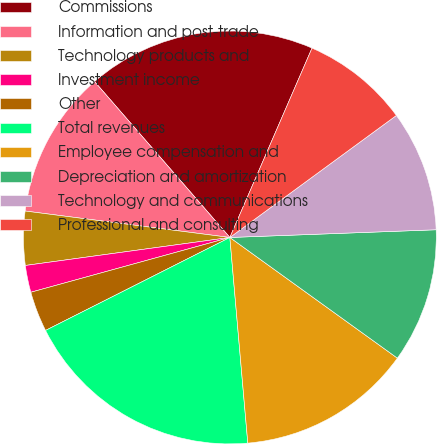Convert chart to OTSL. <chart><loc_0><loc_0><loc_500><loc_500><pie_chart><fcel>Commissions<fcel>Information and post-trade<fcel>Technology products and<fcel>Investment income<fcel>Other<fcel>Total revenues<fcel>Employee compensation and<fcel>Depreciation and amortization<fcel>Technology and communications<fcel>Professional and consulting<nl><fcel>17.89%<fcel>11.58%<fcel>4.21%<fcel>2.11%<fcel>3.16%<fcel>18.95%<fcel>13.68%<fcel>10.53%<fcel>9.47%<fcel>8.42%<nl></chart> 